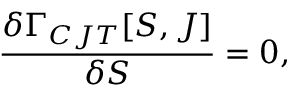Convert formula to latex. <formula><loc_0><loc_0><loc_500><loc_500>\frac { \delta \Gamma _ { C J T } [ S , J ] } { \delta S } = 0 ,</formula> 